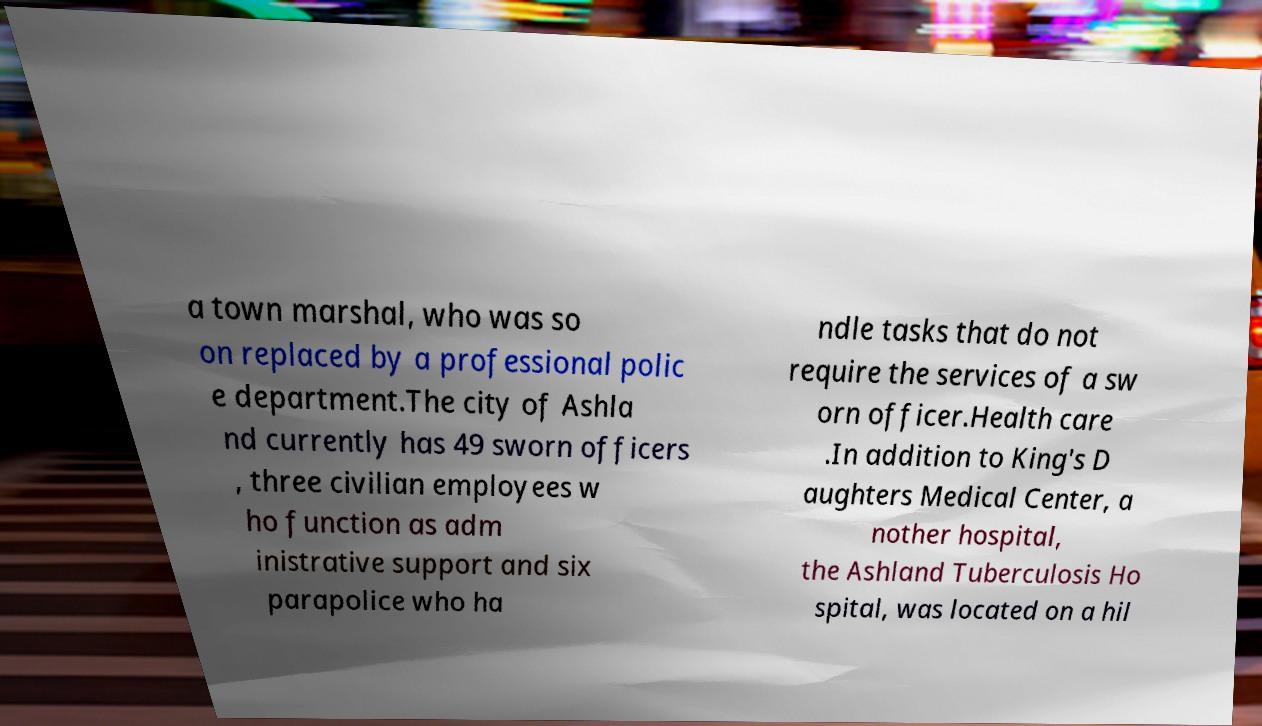Could you extract and type out the text from this image? a town marshal, who was so on replaced by a professional polic e department.The city of Ashla nd currently has 49 sworn officers , three civilian employees w ho function as adm inistrative support and six parapolice who ha ndle tasks that do not require the services of a sw orn officer.Health care .In addition to King's D aughters Medical Center, a nother hospital, the Ashland Tuberculosis Ho spital, was located on a hil 